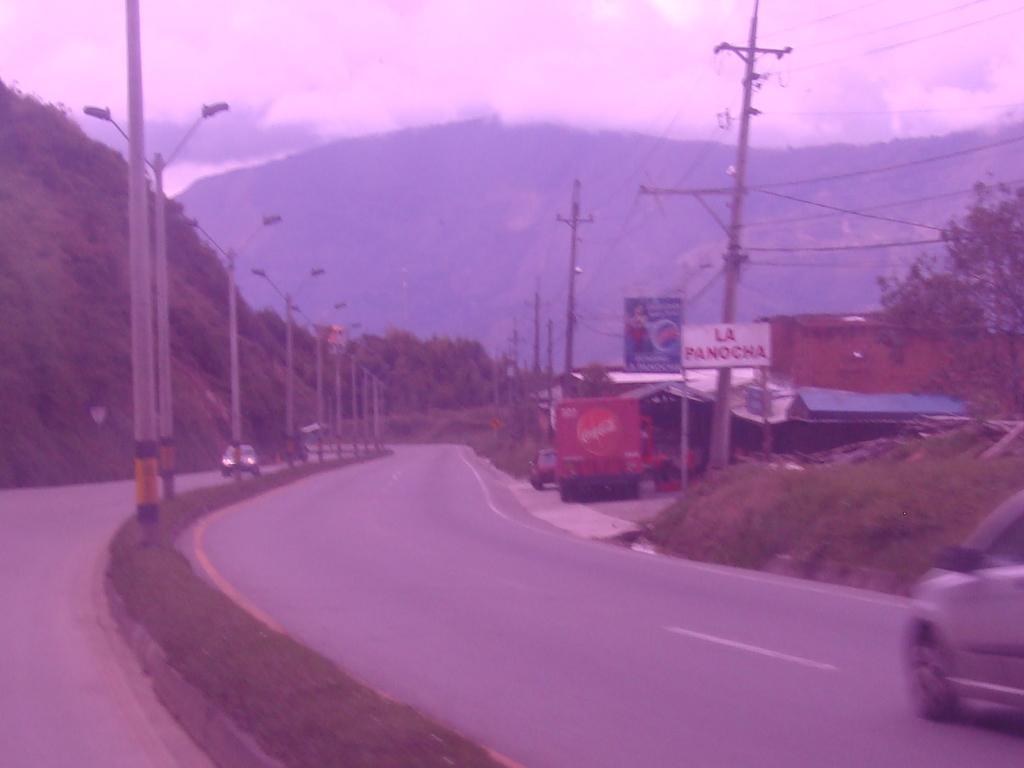Describe this image in one or two sentences. In this picture we can see vehicles on roads, light poles, posters, shed, trees, plants, mountains and some objects and in the background we can see the sky with clouds. 